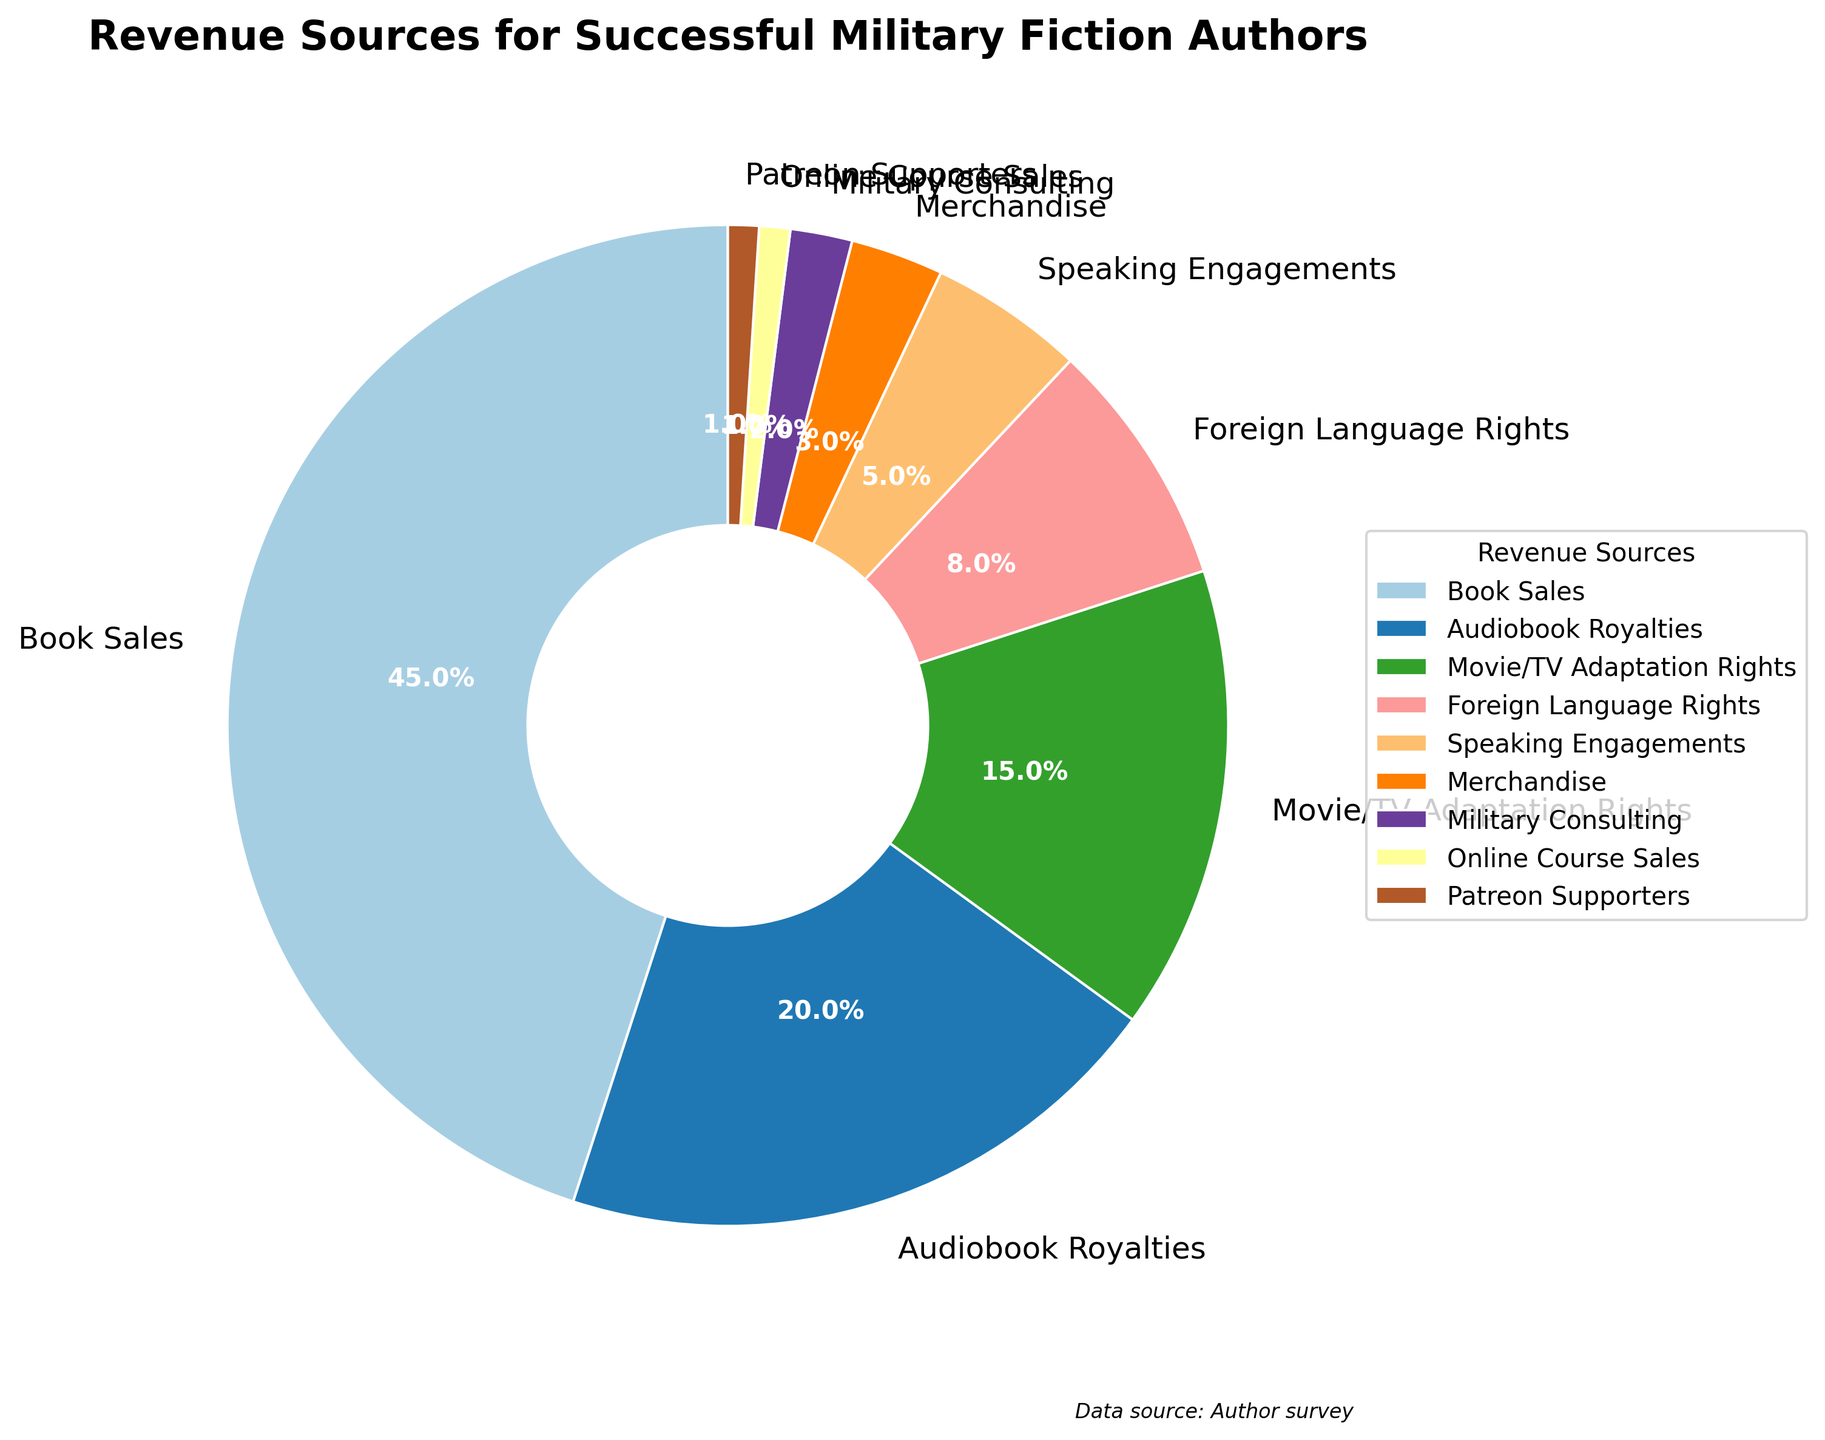Which revenue source contributes the most to the total revenue? The segment representing 'Book Sales' is the largest in the pie chart, indicating it contributes 45% of the total revenue. Therefore, 'Book Sales' is the revenue source with the highest contribution.
Answer: Book Sales How much more does Book Sales contribute than Audiobook Royalties? Book Sales contribute 45% to the total revenue, while Audiobook Royalties contribute 20%. The difference between Book Sales and Audiobook Royalties is 45% - 20% = 25%.
Answer: 25% What is the combined percentage of less significant revenue sources (each contributing less than 10%)? The contributions less than 10% are: Foreign Language Rights (8%), Speaking Engagements (5%), Merchandise (3%), Military Consulting (2%), Online Course Sales (1%), and Patreon Supporters (1%). Summing these percentages, 8% + 5% + 3% + 2% + 1% + 1% = 20%.
Answer: 20% Which revenue source is represented by the smallest segment, and what is its percentage? The smallest segment in the pie chart is 'Patreon Supporters', which contributes 1% to the total revenue. Therefore, 'Patreon Supporters' is the revenue source with the smallest percentage.
Answer: Patreon Supporters, 1% Are speaking engagements more or less significant than movie/TV adaptation rights in terms of revenue? Speaking Engagements contribute 5% to the total revenue, while Movie/TV Adaptation Rights contribute 15%. Since 5% is less than 15%, Speaking Engagements are less significant than Movie/TV Adaptation Rights.
Answer: Less significant Rank the revenue sources from highest to lowest based on their contribution. Based on their contributions, the ranking is: 1) Book Sales (45%), 2) Audiobook Royalties (20%), 3) Movie/TV Adaptation Rights (15%), 4) Foreign Language Rights (8%), 5) Speaking Engagements (5%), 6) Merchandise (3%), 7) Military Consulting (2%), 8) Online Course Sales (1%), 9) Patreon Supporters (1%).
Answer: Book Sales, Audiobook Royalties, Movie/TV Adaptation Rights, Foreign Language Rights, Speaking Engagements, Merchandise, Military Consulting, Online Course Sales, Patreon Supporters Which two revenue sources are closest in percentage, and what is their combined contribution? Online Course Sales (1%) and Patreon Supporters (1%) are closest in percentage as they both contribute 1%. Their combined contribution is 1% + 1% = 2%.
Answer: Online Course Sales and Patreon Supporters, 2% If the revenue from Online Course Sales doubled, what would be the new total percentage for Online Course Sales? Currently, Online Course Sales contribute 1%. If it doubled, it would be 1% * 2 = 2%.
Answer: 2% 